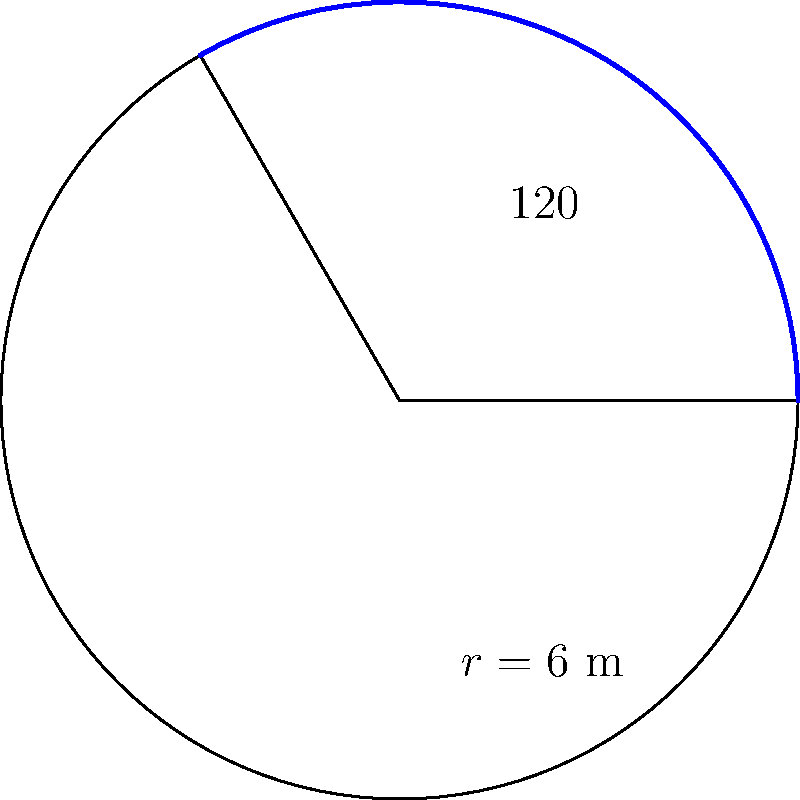For an upcoming sci-fi movie, you need to design a fan-shaped prop that will be used as a futuristic energy shield. The prop is modeled as a sector of a circle with a central angle of 120° and a radius of 6 meters. What is the area of this fan-shaped prop in square meters? To find the area of a circular sector, we can use the formula:

$$A = \frac{\theta}{360°} \pi r^2$$

Where:
$A$ = Area of the sector
$\theta$ = Central angle in degrees
$r$ = Radius of the circle

Given:
$\theta = 120°$
$r = 6$ m

Step 1: Substitute the values into the formula:
$$A = \frac{120°}{360°} \pi (6\text{ m})^2$$

Step 2: Simplify the fraction:
$$A = \frac{1}{3} \pi (6\text{ m})^2$$

Step 3: Calculate the square of the radius:
$$A = \frac{1}{3} \pi (36\text{ m}^2)$$

Step 4: Multiply:
$$A = 12\pi\text{ m}^2$$

Step 5: Calculate the final value (rounded to two decimal places):
$$A \approx 37.70\text{ m}^2$$

Therefore, the area of the fan-shaped prop is approximately 37.70 square meters.
Answer: $37.70\text{ m}^2$ 